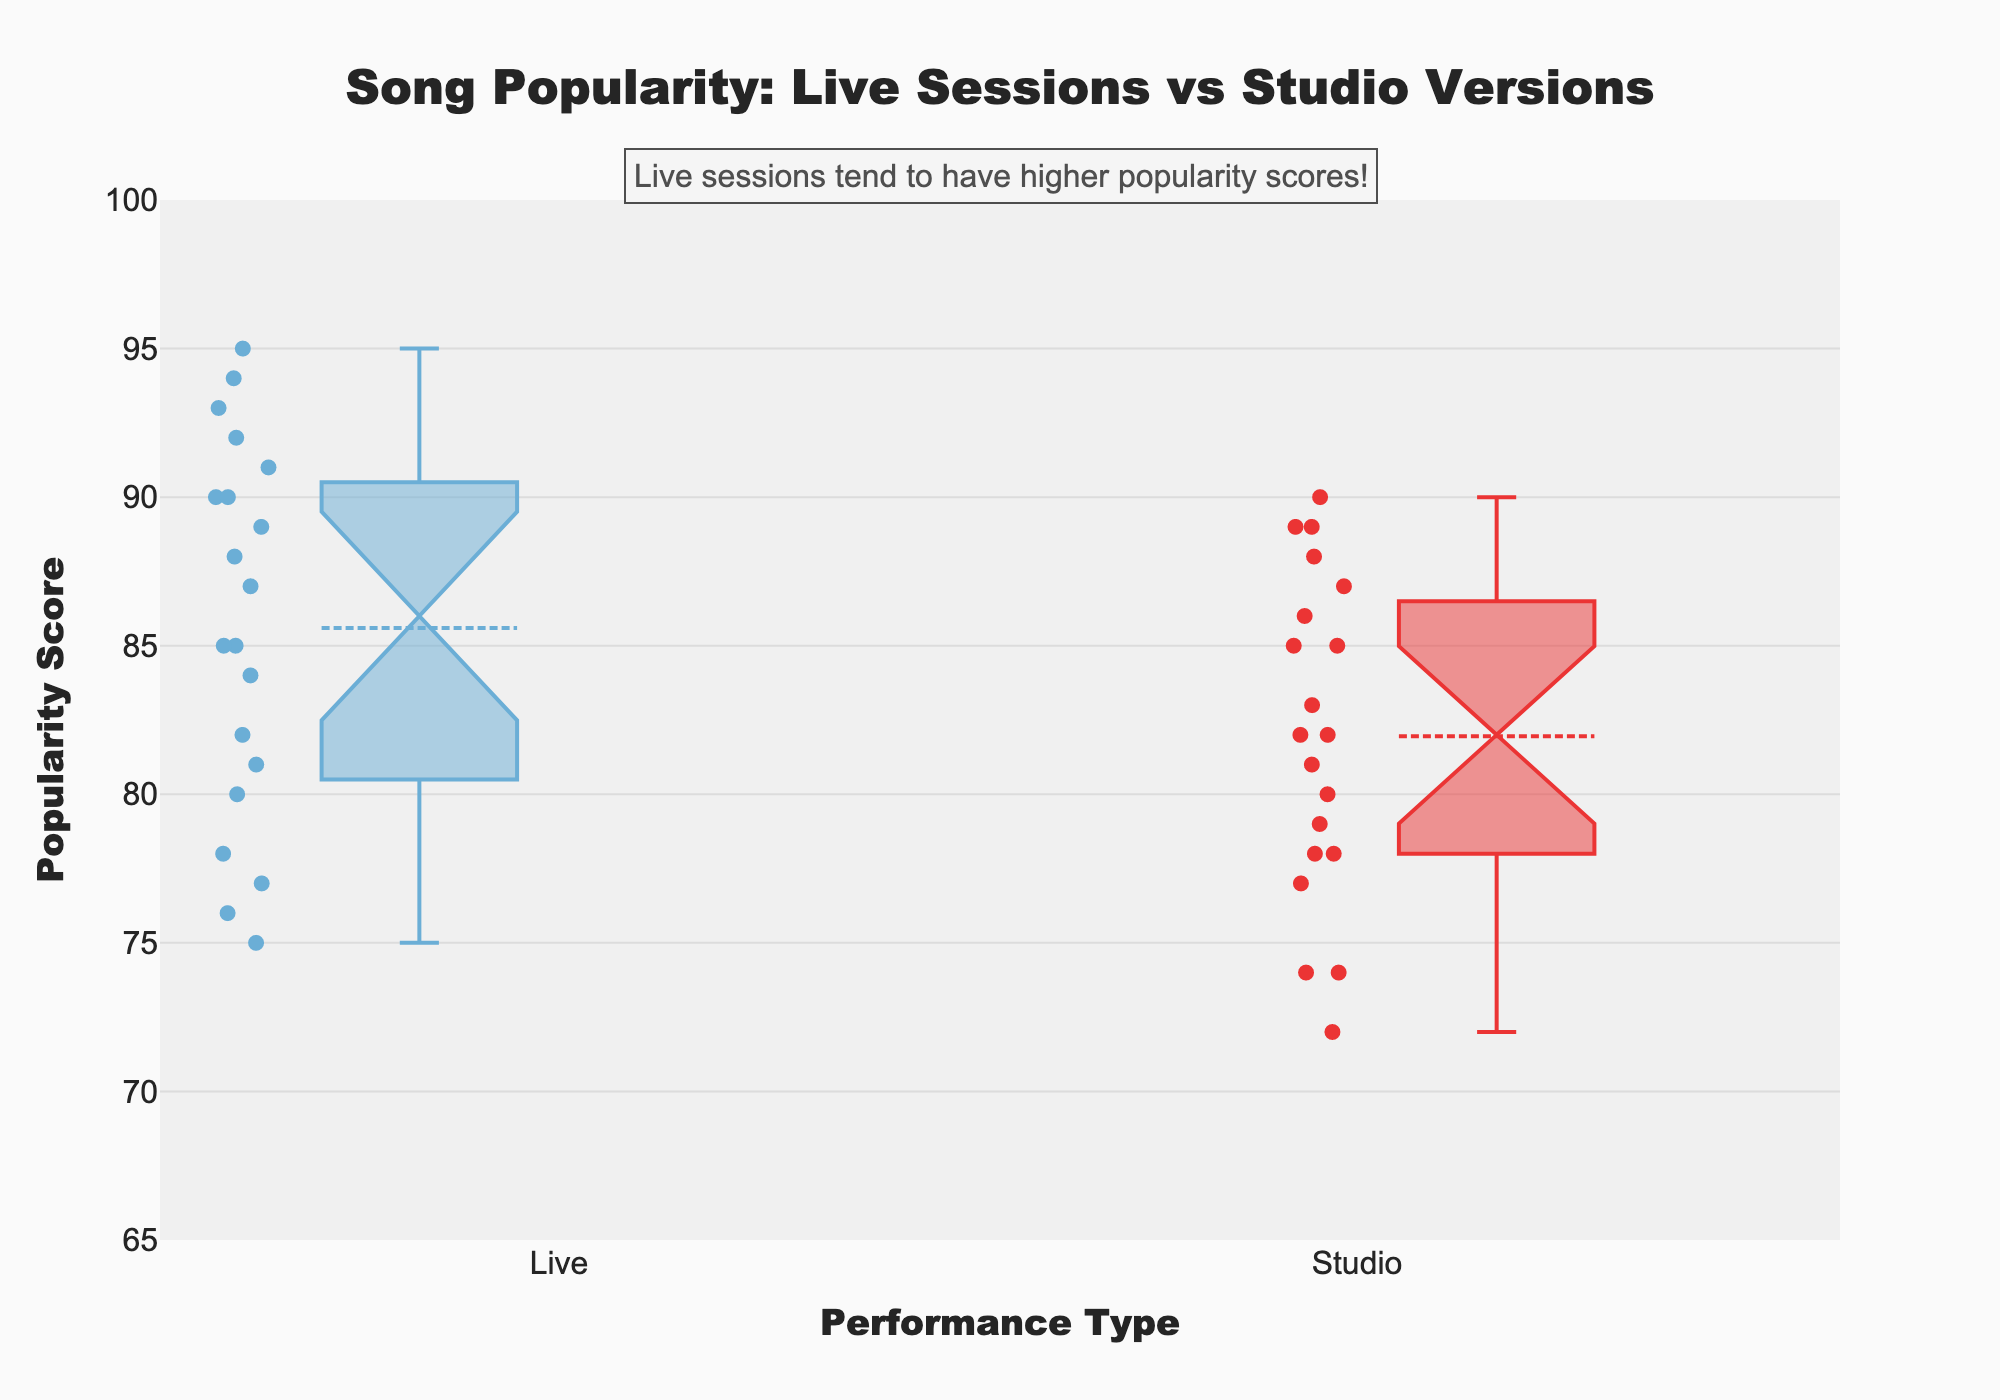What is the title of the figure? The title is typically displayed prominently at the top of the figure. By referring to this area, we can see that the title reads "Song Popularity: Live Sessions vs Studio Versions".
Answer: "Song Popularity: Live Sessions vs Studio Versions" What does the x-axis represent? The label on the x-axis indicates what is being compared in the figure. Here, it is labeled "Performance Type".
Answer: Performance Type What does the y-axis represent? The label on the y-axis shows the metric being measured in the figure. In this case, it is labeled "Popularity Score".
Answer: Popularity Score Which performance type appears to have a higher median popularity score? To determine this, we need to identify the median lines in the box plots for both Live and Studio performances. The median is the line within each box. The median of the Live sessions is higher than that of the Studio versions.
Answer: Live What is the approximate range of popularity scores for Live sessions? The range is determined by the minimum and maximum values within the whiskers of the box plot. For Live sessions, this range appears to be from approximately 75 to 95.
Answer: 75 to 95 How do the mean popularity scores of Live sessions compare to Studio versions? Each box plot includes a mean marker, represented by a dashed line or distinct symbol. By comparing these markers, we see that the mean popularity score for Live sessions is higher than that for Studio versions.
Answer: Higher for Live Which performance type has a wider spread of popularity scores? The spread can be assessed by looking at the length of the boxes and whiskers. The Live performance type shows a wider spread compared to Studio, indicating more variability in popularity scores.
Answer: Live What is the interquartile range (IQR) for the Studio performances? The IQR is the range between the first and third quartiles (the edges of the box). For Studio versions, this range is from approximately 78 to 87.
Answer: 9 Is there any indication that one performance type is statistically significantly different from the other? The notches in the box plots can be used to infer statistical significance. If the notches of two boxes do not overlap, it suggests that there is a significant difference between the medians. Here, the notches do not overlap, indicating a significant difference.
Answer: Yes What is a key insight noted in the annotation on the figure? There is an annotation added to the figure, which highlights a particular insight. It states that "Live sessions tend to have higher popularity scores!".
Answer: Live sessions tend to have higher popularity scores! 